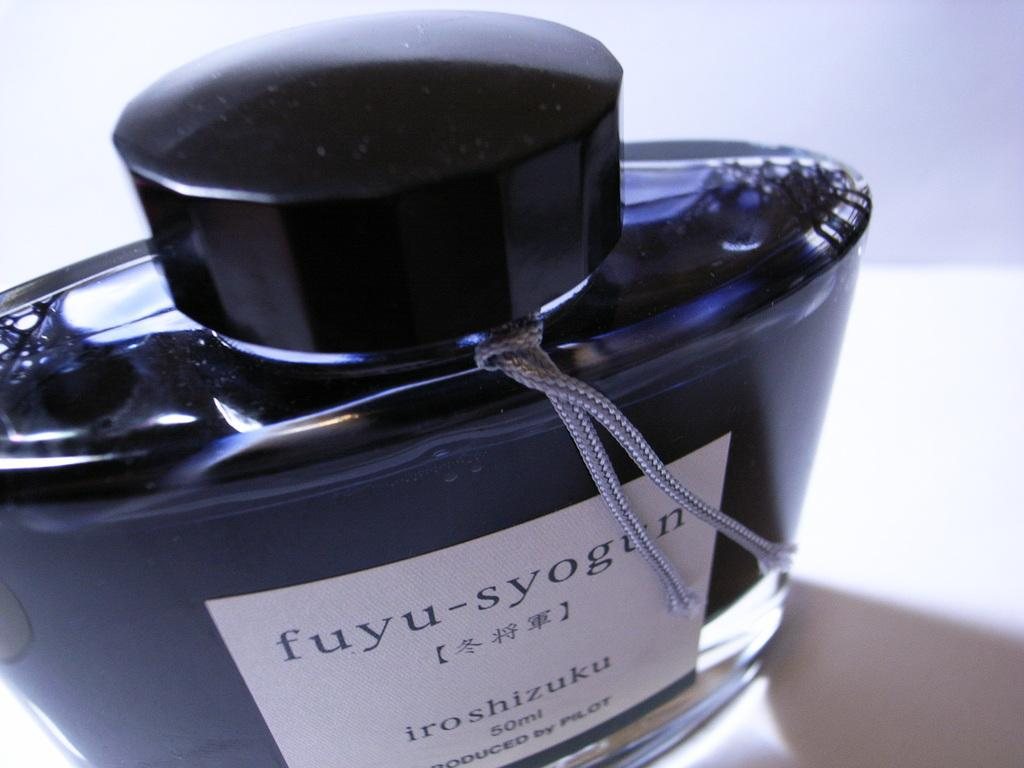<image>
Summarize the visual content of the image. Fuyu syogun iroshizuku fifty ml cologne produced by pilot 